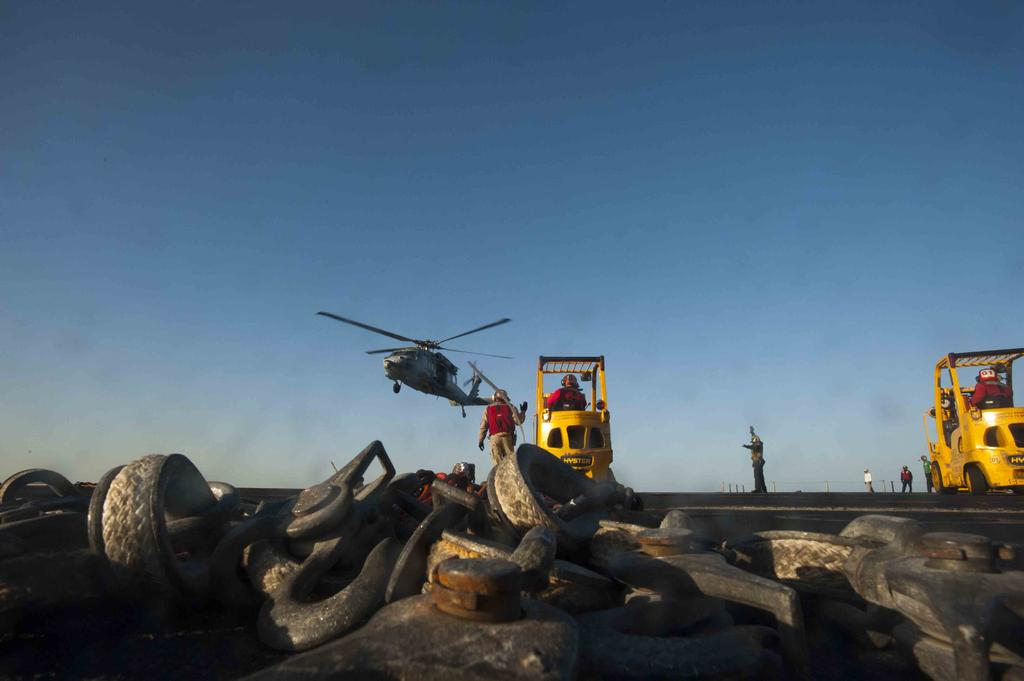What is located in the center of the image? There are persons and vehicles in the center of the image. What can be seen at the bottom of the image? Tires and machinery are visible at the bottom of the image. What is present in the background of the image? There is a helicopter and the sky visible in the background of the image. Where is the cemetery located in the image? There is no cemetery present in the image. What direction are the persons facing in the image? The provided facts do not specify the direction the persons are facing, so it cannot be determined from the image. 